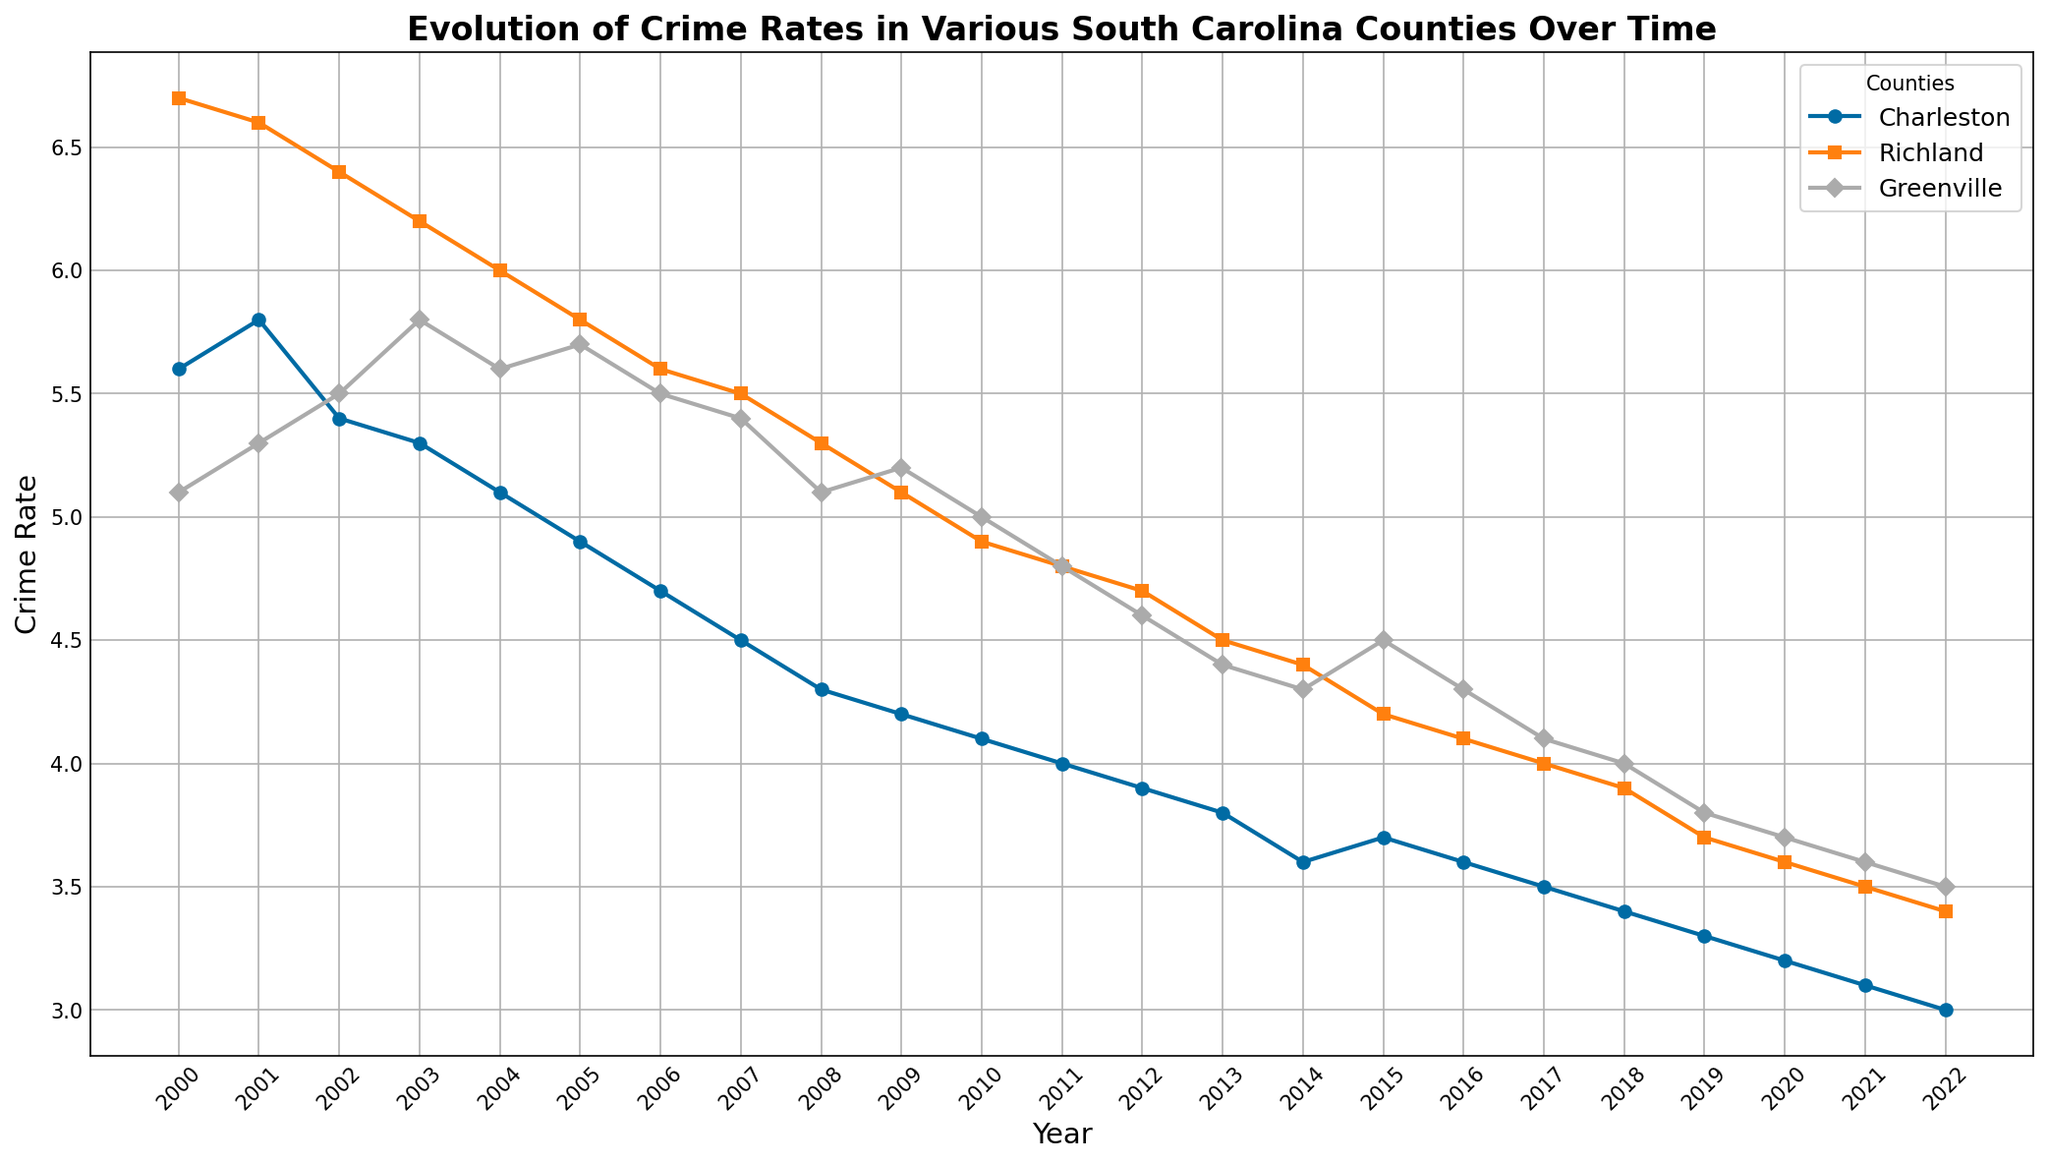Which county had the highest crime rate in 2000? By looking at the values for each county in the year 2000, we can see that Richland had the highest crime rate with a value of 6.7.
Answer: Richland How did the crime rate in Greenville in 2003 compare to the crime rate in Charleston in the same year? The chart needs to show the crime rates for both counties in 2003. Greenville had a crime rate of 5.8, while Charleston had a crime rate of 5.3, indicating that Greenville's crime rate was higher.
Answer: Greenville's crime rate was higher What was the average crime rate in Charleston over the period from 2000 to 2022? To find the average, sum up all the crime rates in Charleston from 2000 to 2022 and then divide it by the number of years (23). The sum is 97.3, so the average is 97.3/23 ≈ 4.23.
Answer: 4.23 Which county showed the largest decline in crime rate from 2000 to 2022? Looking at the trend for each county from 2000 to 2022, Charleston's crime rate dropped from 5.6 to 3.0, Richland's from 6.7 to 3.4, and Greenville's from 5.1 to 3.5. Therefore, Richland showed the largest decline.
Answer: Richland Did the crime rate in any county increase at any point? Examining the lines for each county in the figure, the crime rate in Charleston slightly increased from 2000 to 2001 and from 2014 to 2015.
Answer: Yes What was the crime rate trend in Charleston from 2007 to 2012? The chart shows that Charleston’s crime rate steadily declined each year from 4.5 in 2007 to 3.9 in 2012.
Answer: Steadily declined Which county had the lowest crime rate in 2013? Referring to the values for 2013 in the figure, Charleston had a crime rate of 3.8, Richland 4.5, and Greenville 4.4. Therefore, Charleston had the lowest crime rate.
Answer: Charleston What's the difference in crime rates between Richland and Greenville in 2010? The chart indicates that Richland had a crime rate of 4.9 and Greenville had 5.0 in 2010. The difference is 5.0 - 4.9 = 0.1.
Answer: 0.1 During which year did Richland’s crime rate dip below 6.0 for the first time? From the graph, we see that Richland's crime rate first fell below 6.0 in 2004, where it registered a rate of 6.0 exactly.
Answer: 2004 